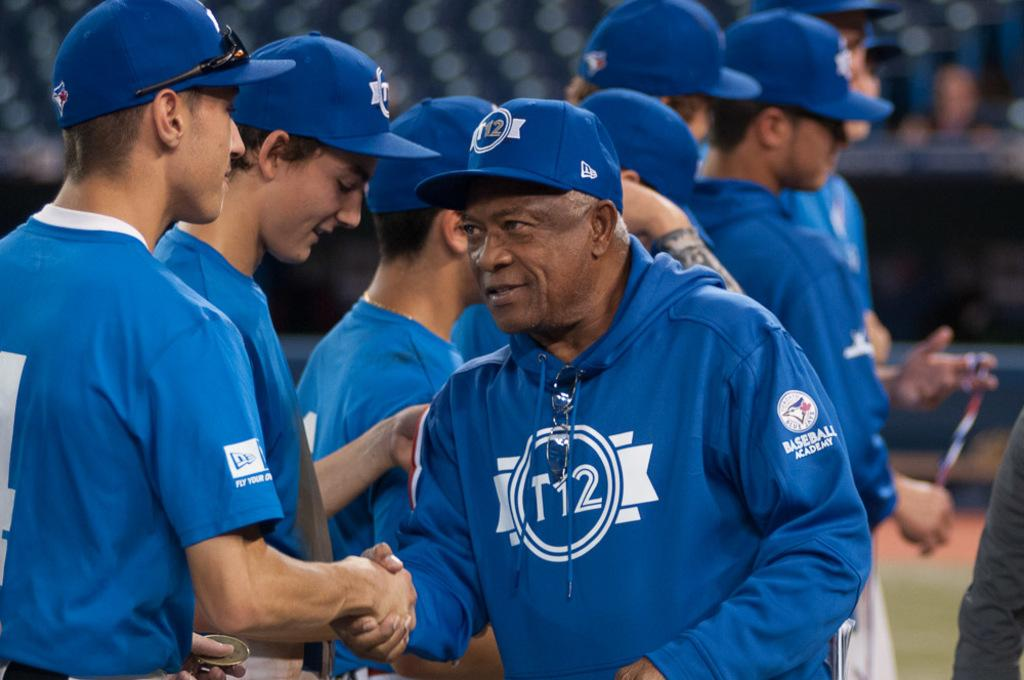Provide a one-sentence caption for the provided image. Man wearing a blue hoodie which says T12 on it. 